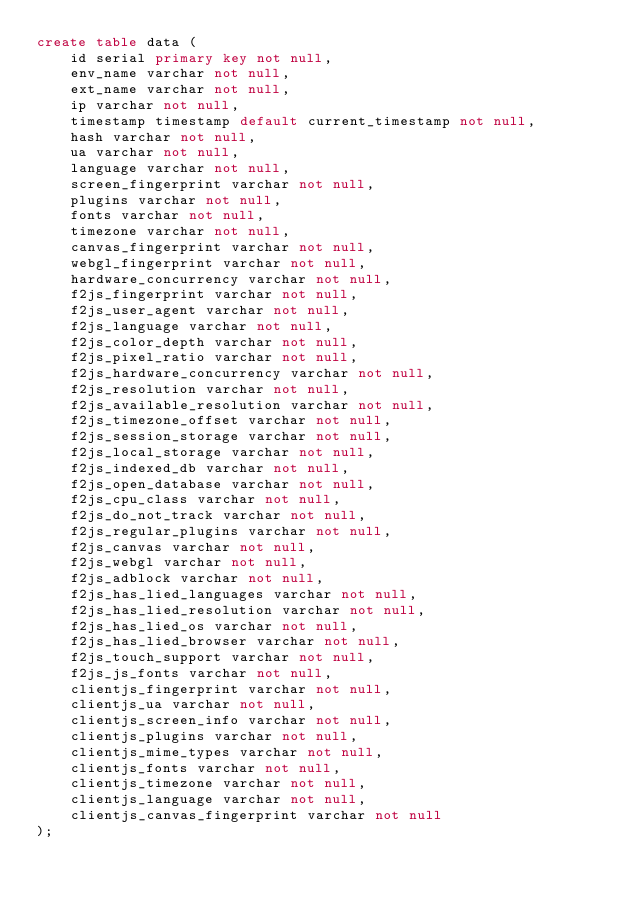<code> <loc_0><loc_0><loc_500><loc_500><_SQL_>create table data (
    id serial primary key not null,
    env_name varchar not null,
    ext_name varchar not null,
    ip varchar not null,
    timestamp timestamp default current_timestamp not null,
    hash varchar not null,
    ua varchar not null,
    language varchar not null,
    screen_fingerprint varchar not null,
    plugins varchar not null,
    fonts varchar not null,
    timezone varchar not null,
    canvas_fingerprint varchar not null,
    webgl_fingerprint varchar not null,
    hardware_concurrency varchar not null,
    f2js_fingerprint varchar not null,
    f2js_user_agent varchar not null,
    f2js_language varchar not null,
    f2js_color_depth varchar not null,
    f2js_pixel_ratio varchar not null,
    f2js_hardware_concurrency varchar not null,
    f2js_resolution varchar not null,
    f2js_available_resolution varchar not null,
    f2js_timezone_offset varchar not null,
    f2js_session_storage varchar not null,
    f2js_local_storage varchar not null,
    f2js_indexed_db varchar not null,
    f2js_open_database varchar not null,
    f2js_cpu_class varchar not null,
    f2js_do_not_track varchar not null,
    f2js_regular_plugins varchar not null,
    f2js_canvas varchar not null,
    f2js_webgl varchar not null,
    f2js_adblock varchar not null,
    f2js_has_lied_languages varchar not null,
    f2js_has_lied_resolution varchar not null,
    f2js_has_lied_os varchar not null,
    f2js_has_lied_browser varchar not null,
    f2js_touch_support varchar not null,
    f2js_js_fonts varchar not null,
    clientjs_fingerprint varchar not null,
    clientjs_ua varchar not null,
    clientjs_screen_info varchar not null,
    clientjs_plugins varchar not null,
    clientjs_mime_types varchar not null,
    clientjs_fonts varchar not null,
    clientjs_timezone varchar not null,
    clientjs_language varchar not null,
    clientjs_canvas_fingerprint varchar not null
);
</code> 